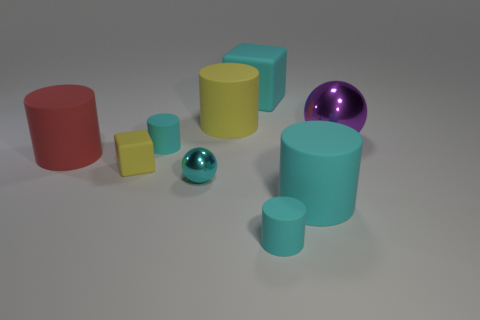Does the tiny cyan ball have the same material as the large cyan object behind the tiny yellow cube?
Offer a terse response. No. What size is the metal thing that is the same color as the large block?
Offer a terse response. Small. How many other objects are there of the same shape as the small shiny object?
Offer a very short reply. 1. What is the color of the matte cube that is the same size as the cyan sphere?
Your response must be concise. Yellow. Is the number of big red rubber things that are on the right side of the big red rubber cylinder less than the number of tiny yellow cubes that are right of the purple ball?
Keep it short and to the point. No. How many blocks are to the left of the shiny sphere in front of the tiny rubber cylinder behind the big cyan rubber cylinder?
Give a very brief answer. 1. The other shiny object that is the same shape as the small cyan metallic thing is what size?
Keep it short and to the point. Large. Are there fewer tiny cyan things that are behind the red matte cylinder than big cylinders?
Provide a succinct answer. Yes. Is the shape of the big metal thing the same as the red matte thing?
Your answer should be compact. No. There is another tiny thing that is the same shape as the purple metal object; what color is it?
Give a very brief answer. Cyan. 